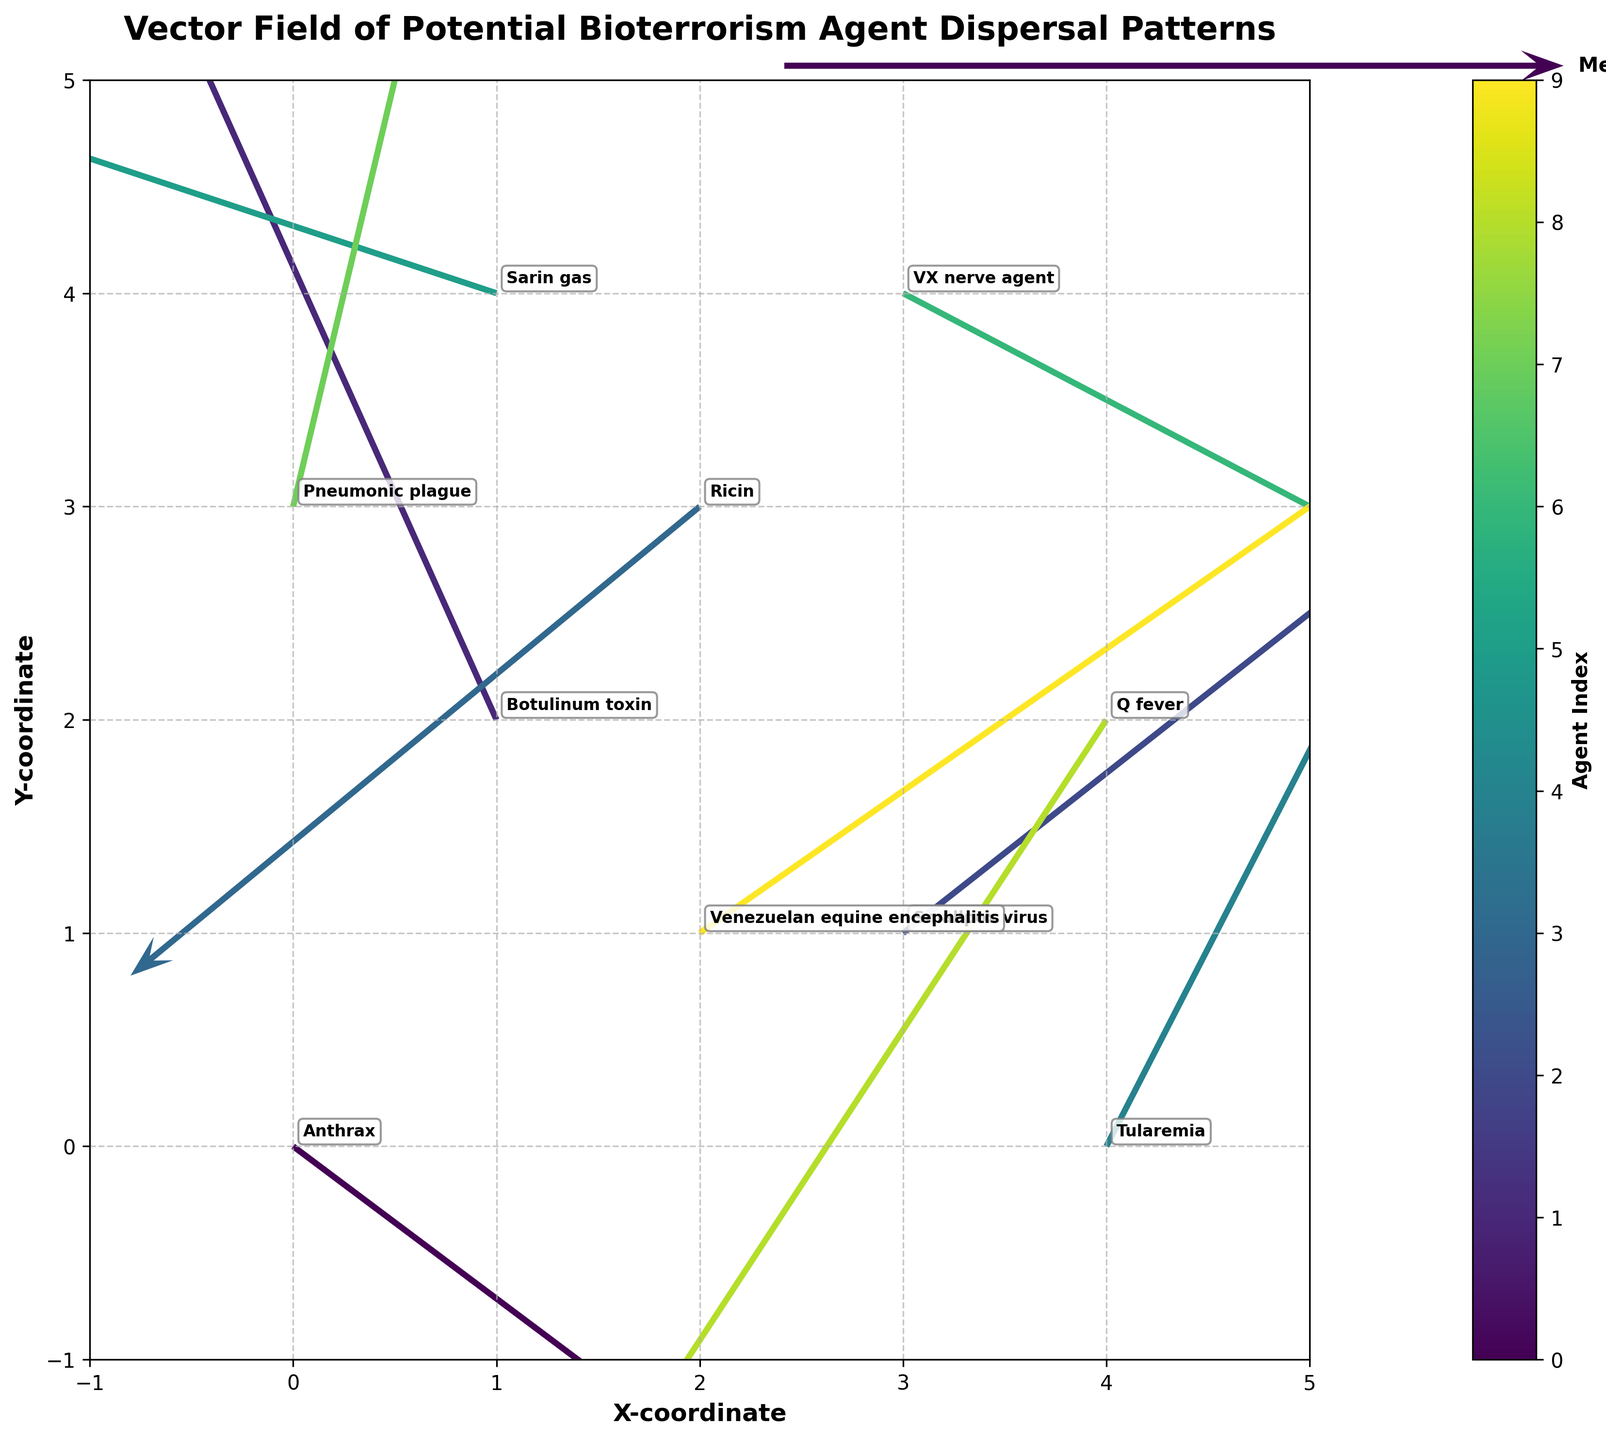What is the title of the plot? The title of the plot is visible at the top of the figure. It reads "Vector Field of Potential Bioterrorism Agent Dispersal Patterns".
Answer: Vector Field of Potential Bioterrorism Agent Dispersal Patterns Which agent starts at the coordinates (1,2)? The agent names are annotated next to their starting coordinates. At (1,2), the agent is labeled as "Botulinum toxin".
Answer: Botulinum toxin What are the units for the X and Y axes? The labels for the X and Y axes can be seen along the respective axes of the figure. They are "X-coordinate" and "Y-coordinate".
Answer: X-coordinate and Y-coordinate How many agents are represented in the figure? Each quiver (arrow) represents a unique bioterrorism agent, and each one is annotated on the plot. Counting these annotations indicates there are 10 agents.
Answer: 10 Which agent has the highest starting X-coordinate? Checking the X-coordinates of each agent, the one at the highest value (4,0) is labeled as "Tularemia".
Answer: Tularemia Which agent shows the most movement in the positive Y direction? This can be determined by examining the arrows pointing upwards with a significant length. "Pneumonic plague" at (0,3) has a vector pointing directly up with a value of 2.0.
Answer: Pneumonic plague Compare the vectors for "Sarin gas" and "Ricin". Which one has a higher magnitude? To determine the magnitude of each vector, calculate the Euclidean distance: sqrt(u^2 + v^2). Sarin gas ( -1.9^2 + 0.6^2)= 4.06, sqrt(4.06) = 2.01. Ricin (-1.4^2 + -1.1^2)= 3.17, sqrt(3.17) = 1.78. Sarin gas has a higher magnitude.
Answer: Sarin gas Which agent's dispersal pattern is moving towards the bottom-left direction? The bottom-left direction is indicated by negative values for both u and v. "Ricin" at position (2,3) has u=-1.4 and v=-1.1.
Answer: Ricin How does the vector direction for "Venezuelan equine encephalitis" differ from "Q fever"? "Venezuelan equine encephalitis" at (2,1) shows a vector pointing up and to the right (u=1.8, v=1.2), while "Q fever" at (4,2) points down and to the left (u=-1.1, v=-1.6).
Answer: VEE points up-right, Q fever points down-left 